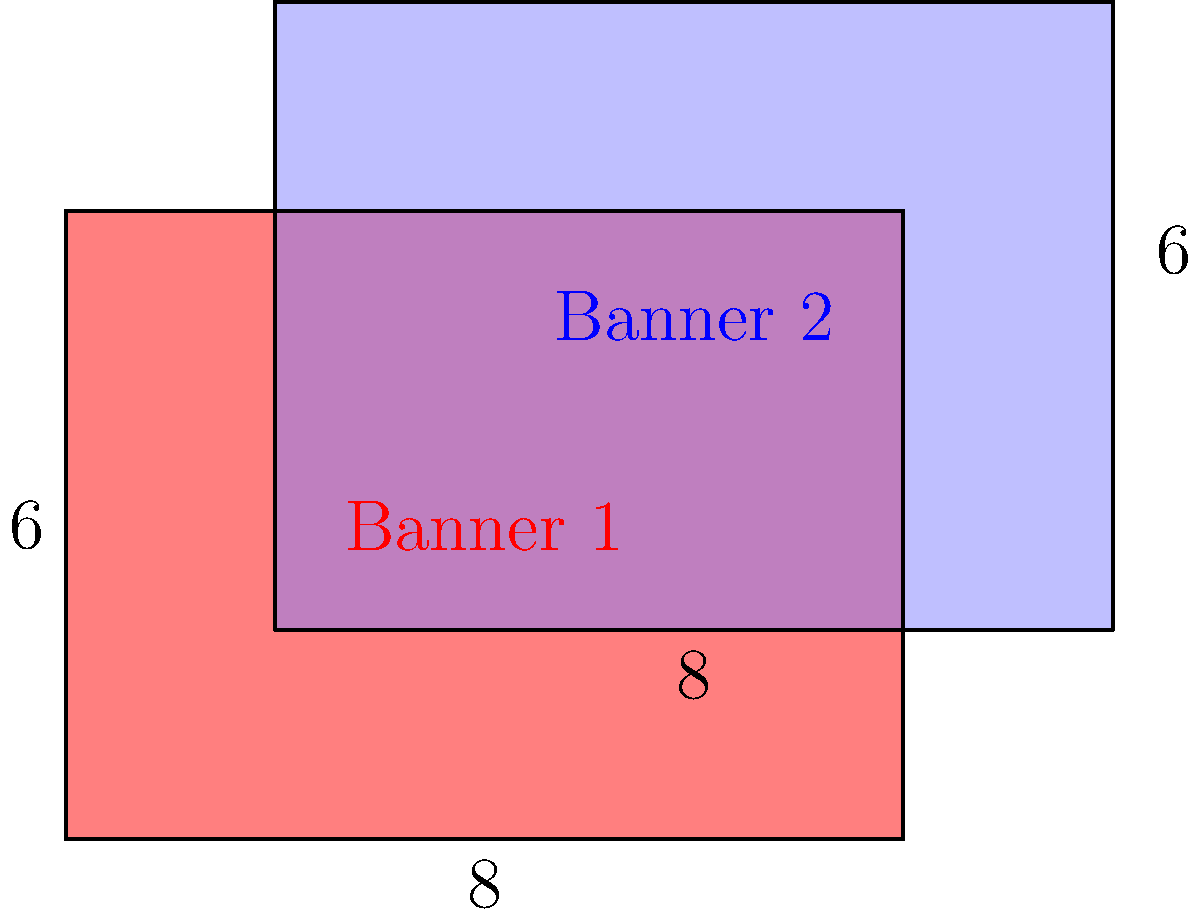During a protest, two rectangular banners overlap as shown in the diagram. Banner 1 (red) measures 8 units by 6 units, while Banner 2 (blue) measures 8 units by 6 units. The overlapping region starts 2 units from the left edge of Banner 1 and 2 units from the bottom edge of Banner 2. Calculate the total visible area of both banners combined. To find the total visible area, we need to:

1. Calculate the area of Banner 1:
   $A_1 = 8 \times 6 = 48$ square units

2. Calculate the area of Banner 2:
   $A_2 = 8 \times 6 = 48$ square units

3. Calculate the area of the overlapping region:
   Width of overlap = $8 - 2 = 6$ units
   Height of overlap = $6 - 2 = 4$ units
   $A_{overlap} = 6 \times 4 = 24$ square units

4. Calculate the total visible area:
   $A_{total} = A_1 + A_2 - A_{overlap}$
   $A_{total} = 48 + 48 - 24 = 72$ square units

Therefore, the total visible area of both banners combined is 72 square units.
Answer: 72 square units 